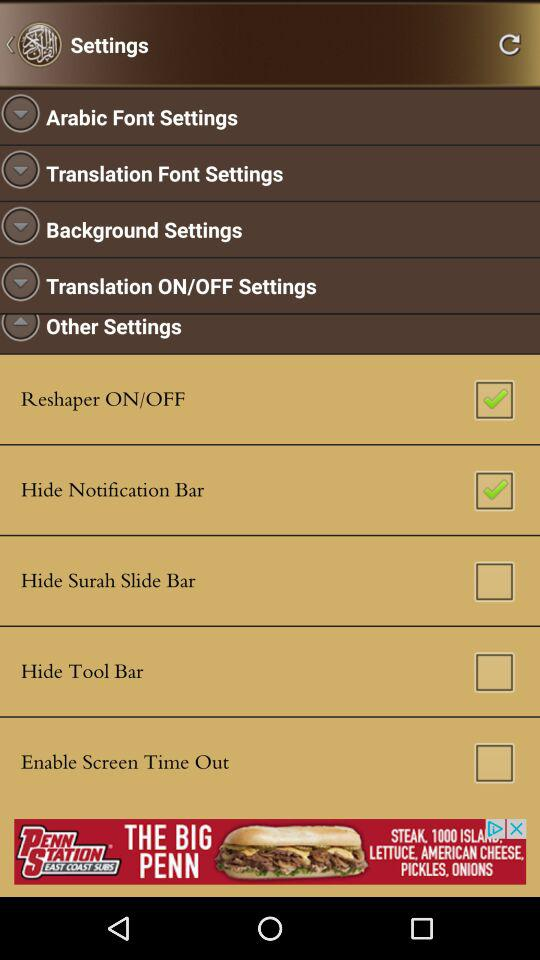What is the status of the "Hide Notification Bar"? The status is "on". 